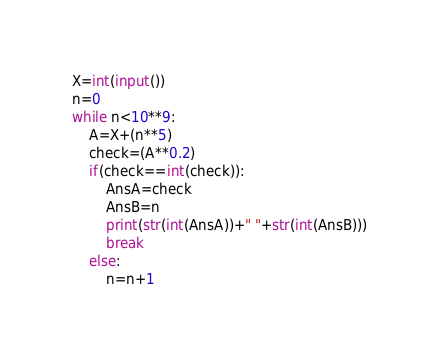<code> <loc_0><loc_0><loc_500><loc_500><_Python_>X=int(input())
n=0
while n<10**9:
    A=X+(n**5)
    check=(A**0.2)
    if(check==int(check)):
        AnsA=check
        AnsB=n
        print(str(int(AnsA))+" "+str(int(AnsB)))
        break
    else:
        n=n+1</code> 